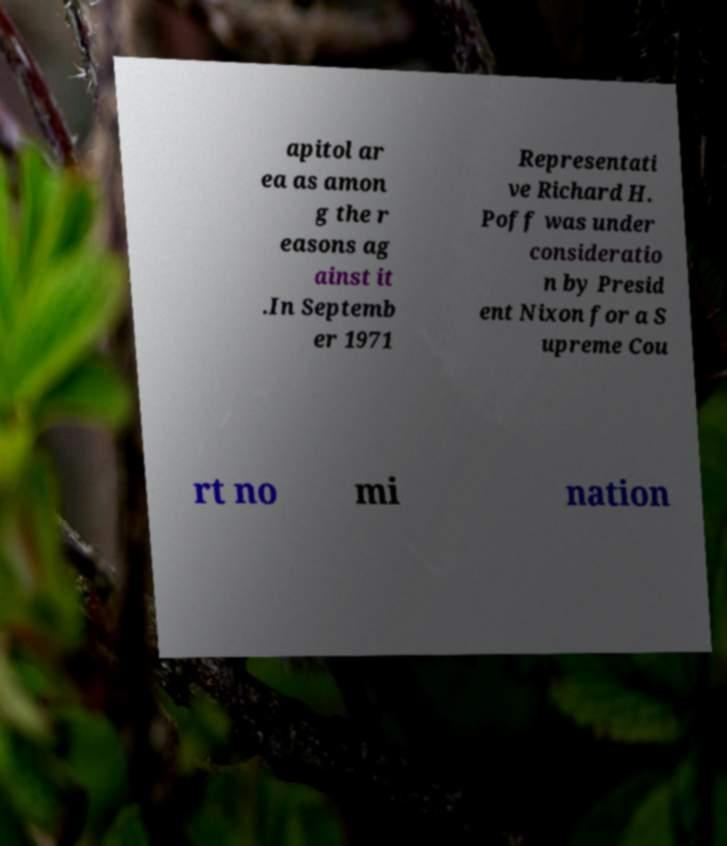There's text embedded in this image that I need extracted. Can you transcribe it verbatim? apitol ar ea as amon g the r easons ag ainst it .In Septemb er 1971 Representati ve Richard H. Poff was under consideratio n by Presid ent Nixon for a S upreme Cou rt no mi nation 